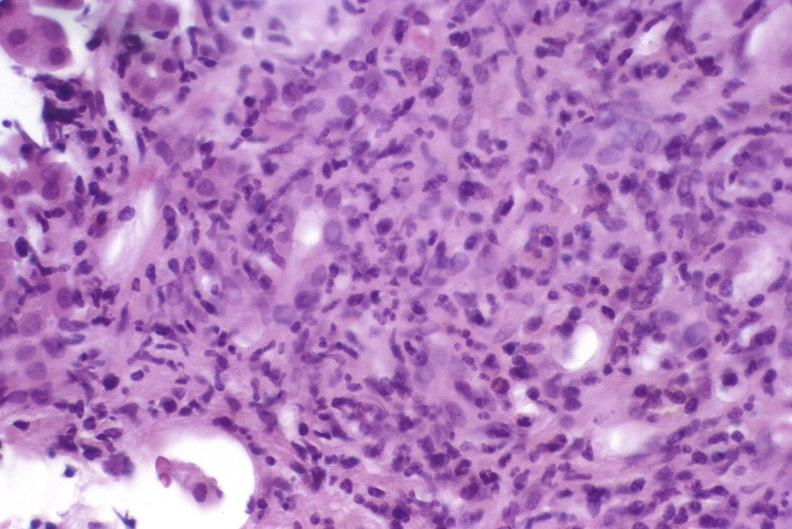s all the fat necrosis present?
Answer the question using a single word or phrase. No 